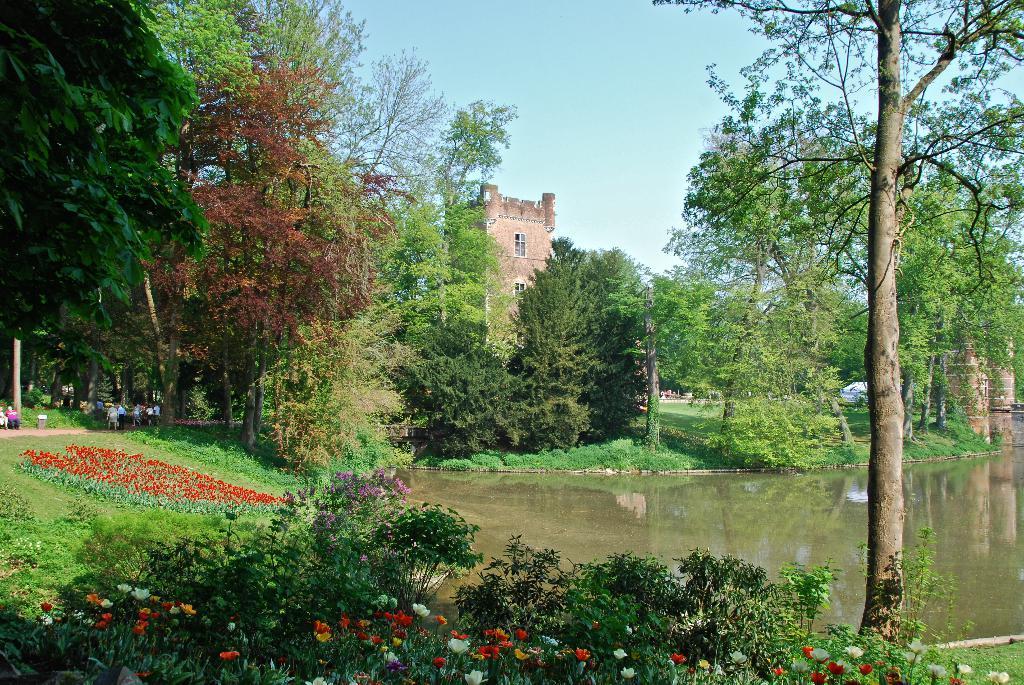Could you give a brief overview of what you see in this image? In this picture we can see flowers, water, trees, building with windows and some persons and in the background we can see the sky. 